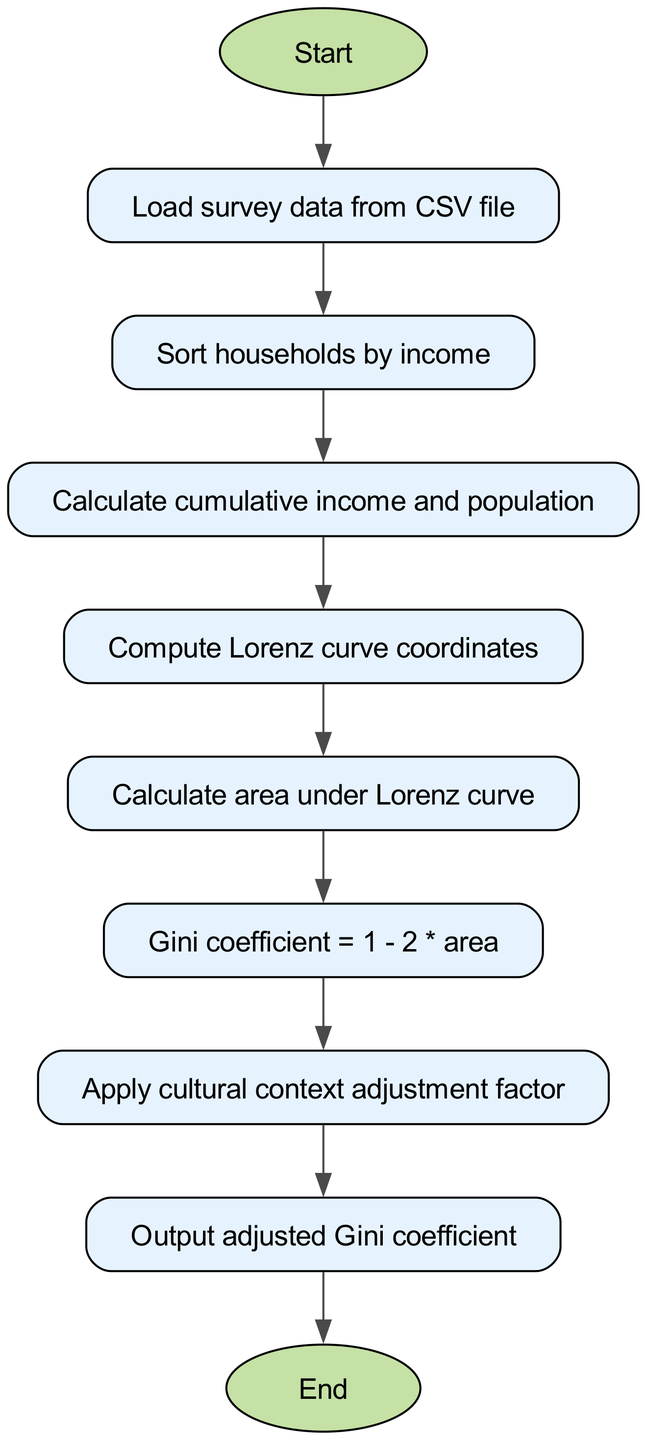What is the first step in the algorithm? The first step is to "Start". The flowchart initiates with a start node that indicates the beginning of the algorithm.
Answer: Start How many steps are involved in this algorithm? There are a total of 9 steps, counting from "Start" to "End" in the flowchart. Each labeled node represents a distinct step in the process, including the final output.
Answer: 9 What happens after loading the survey data? After loading the survey data, the next step is to "Sort households by income". The flow flows directly from the "Load survey data" node to this subsequent step.
Answer: Sort households by income What is calculated before the Gini coefficient? Before calculating the Gini coefficient, "Calculate area under Lorenz curve" is determined. The flowchart shows that calculating the area comes prior to the Gini coefficient step.
Answer: Calculate area under Lorenz curve Which step applies an adjustment factor? The step that applies an adjustment factor is "Apply cultural context adjustment factor". This indicates that adjustments are made to cater to the specific cultural aspects before finalizing the Gini coefficient.
Answer: Apply cultural context adjustment factor How is the Gini coefficient calculated from the area? The Gini coefficient is calculated using the formula "Gini coefficient = 1 - 2 * area". This shows how the area calculated influences the Gini coefficient value through a mathematical formula.
Answer: Gini coefficient = 1 - 2 * area What step comes after computing the Lorenz curve? After computing the Lorenz curve, the next step is "Calculate area under Lorenz curve". It follows sequentially in the flowchart, linking these two stages of the process.
Answer: Calculate area under Lorenz curve What is the outcome of the last step? The outcome of the last step is to "Output adjusted Gini coefficient". This finalizes the process by providing the adjusted value based on prior calculations.
Answer: Output adjusted Gini coefficient In which step is the survey data initially processed? The survey data is initially processed in the step "Load survey data from CSV file". This is where the data needed for calculations is obtained.
Answer: Load survey data from CSV file 